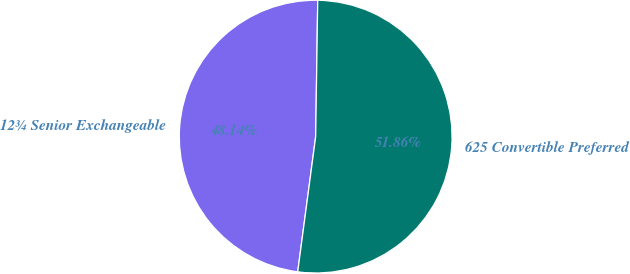Convert chart. <chart><loc_0><loc_0><loc_500><loc_500><pie_chart><fcel>12¾ Senior Exchangeable<fcel>625 Convertible Preferred<nl><fcel>48.14%<fcel>51.86%<nl></chart> 